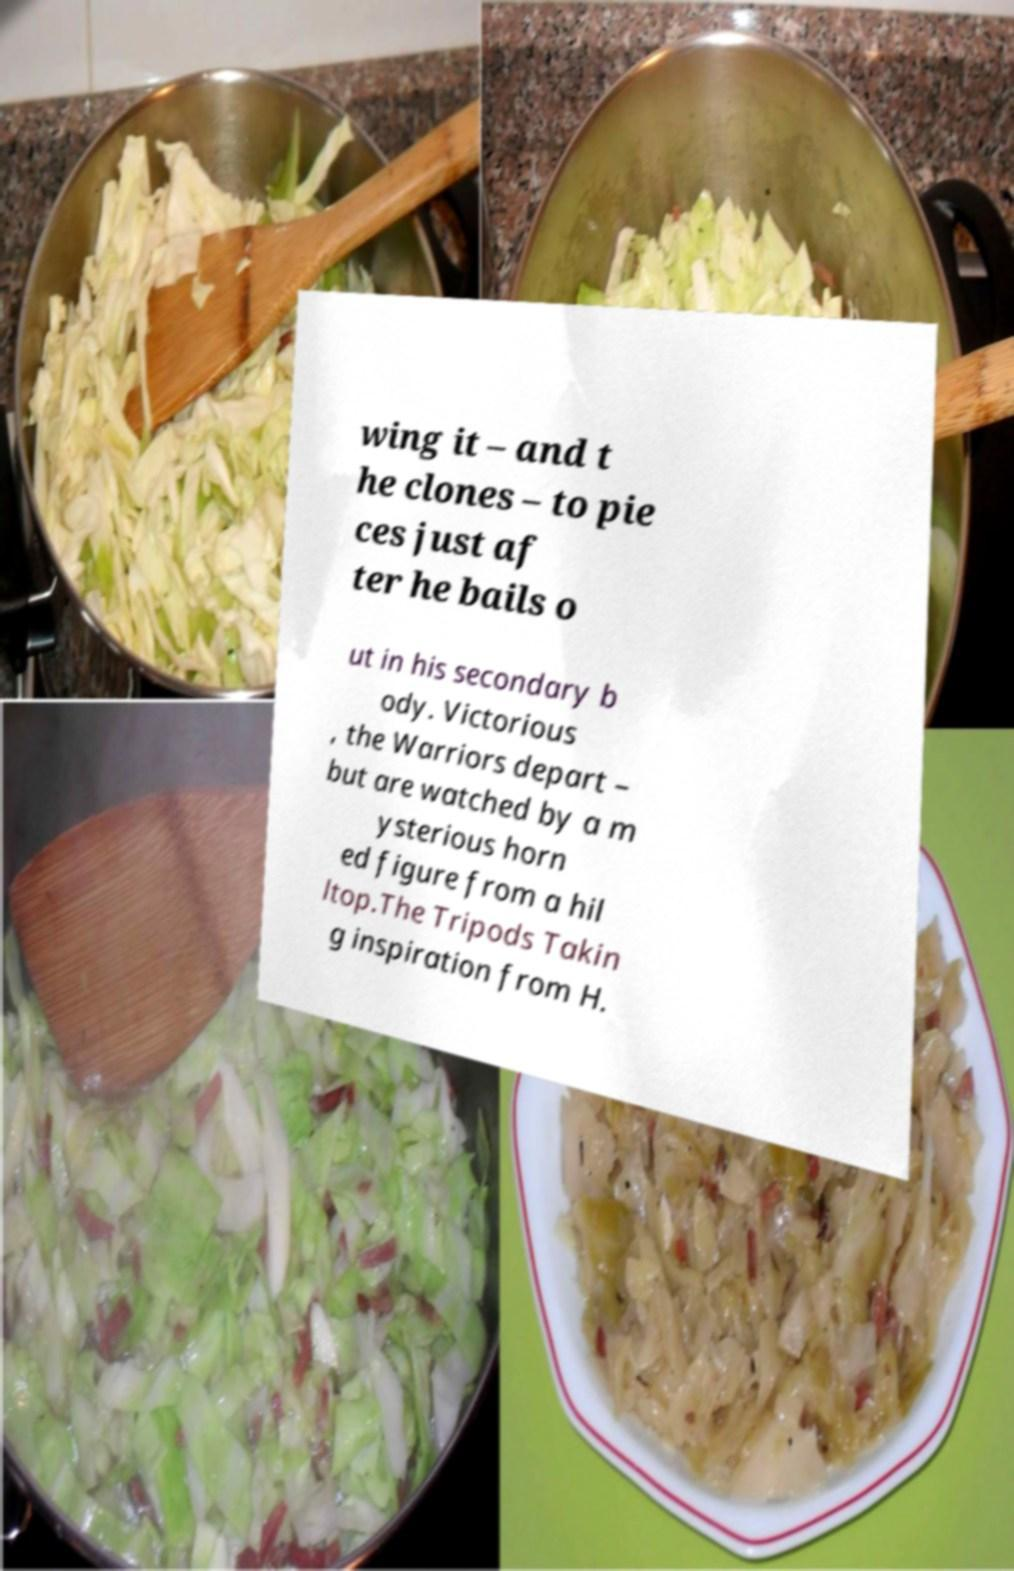Could you assist in decoding the text presented in this image and type it out clearly? wing it – and t he clones – to pie ces just af ter he bails o ut in his secondary b ody. Victorious , the Warriors depart – but are watched by a m ysterious horn ed figure from a hil ltop.The Tripods Takin g inspiration from H. 